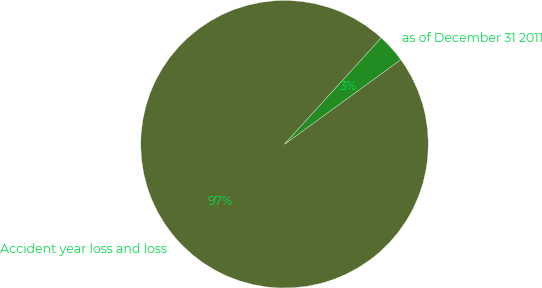Convert chart to OTSL. <chart><loc_0><loc_0><loc_500><loc_500><pie_chart><fcel>Accident year loss and loss<fcel>as of December 31 2011<nl><fcel>96.75%<fcel>3.25%<nl></chart> 